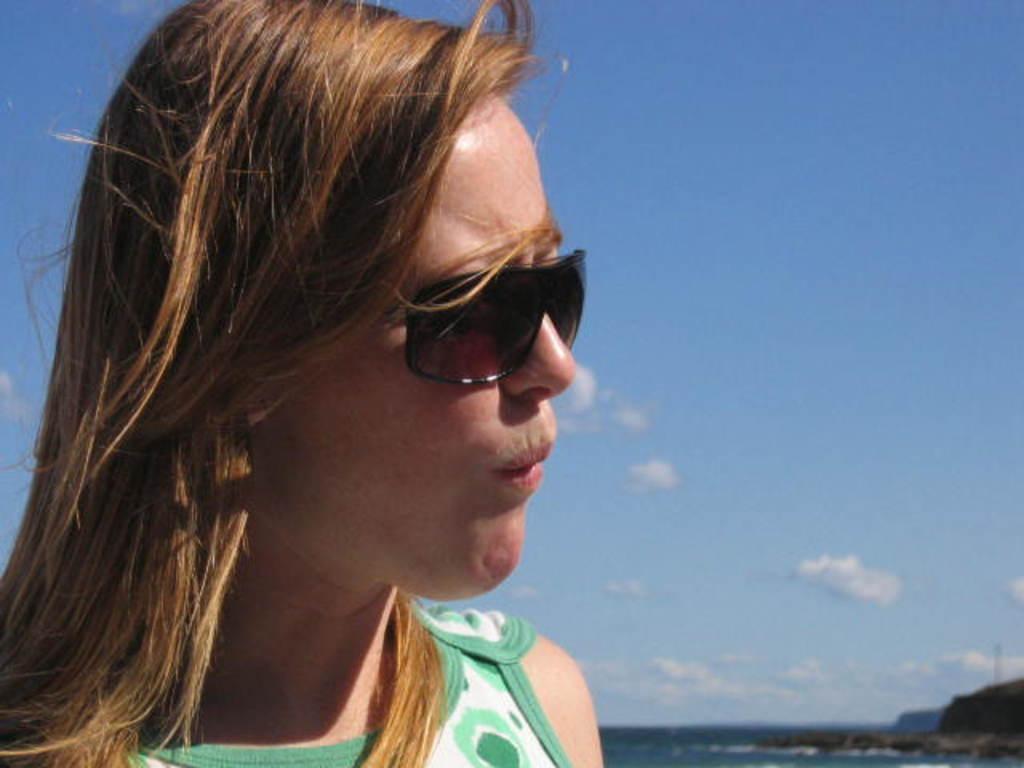Can you describe this image briefly? On the left side of this image I can see a woman wearing green color dress, black color goggles and looking towards the right side. In the background I can see the water and a rock. On the top of the image I can see the sky and clouds. 